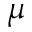<formula> <loc_0><loc_0><loc_500><loc_500>\mu</formula> 